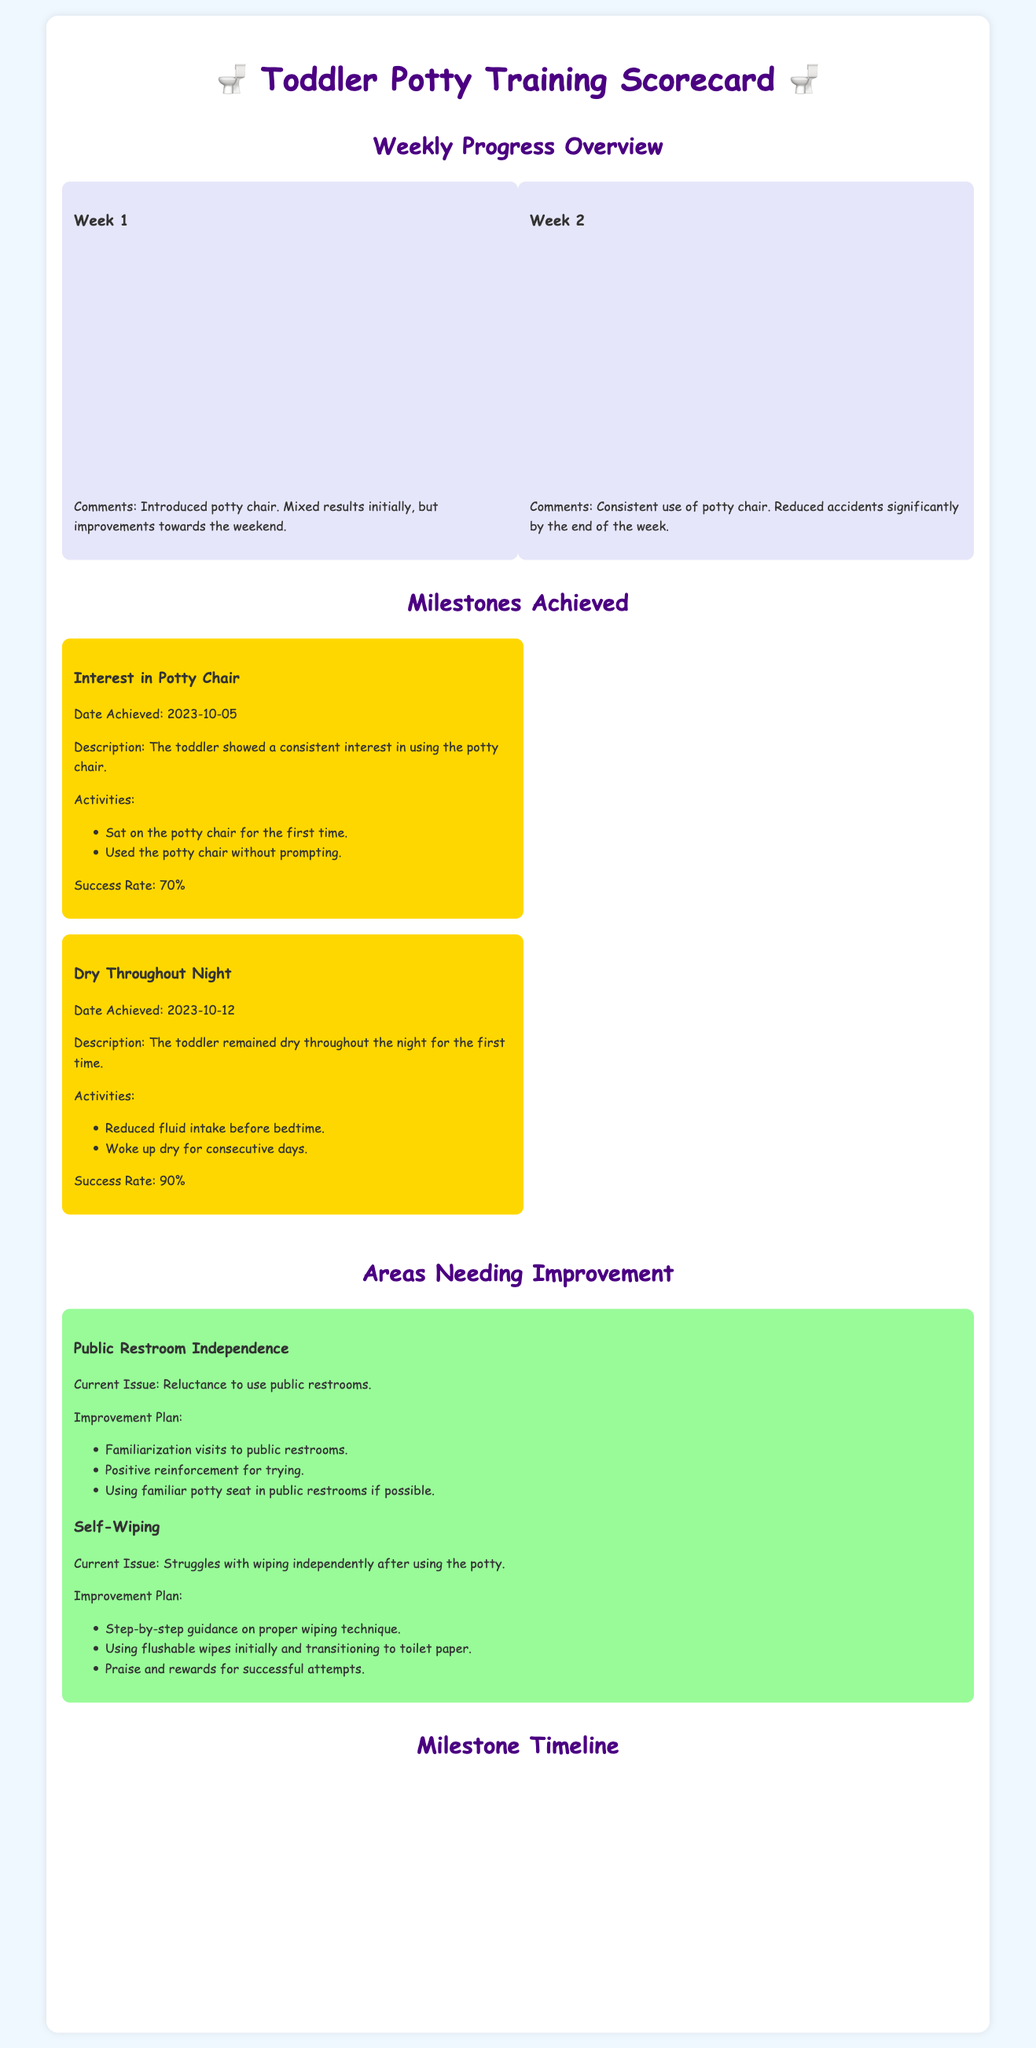What was the success rate on Friday of Week 1? The success rate on Friday of Week 1 is shown in the chart under the "Success Rate (%)" dataset, which is 80%.
Answer: 80% What milestone was achieved on October 12, 2023? The milestone achieved on that date is documented in the "Milestones Achieved" section, specifically "Dry Throughout Night."
Answer: Dry Throughout Night What percentage completion did the toddler reach by the end of Week 2? The success rate for the final day of Week 2 is indicated in the chart, reaching 100% on Sunday.
Answer: 100% What current issue does the toddler face regarding public restrooms? The document outlines the "Current Issue" in the "Areas Needing Improvement" section, stating the toddler has reluctance to use public restrooms.
Answer: Reluctance to use public restrooms How many milestones have been achieved according to the timeline? The milestones are counted in the "Milestone Timeline" section, which indicates 2 milestones have been reached.
Answer: 2 